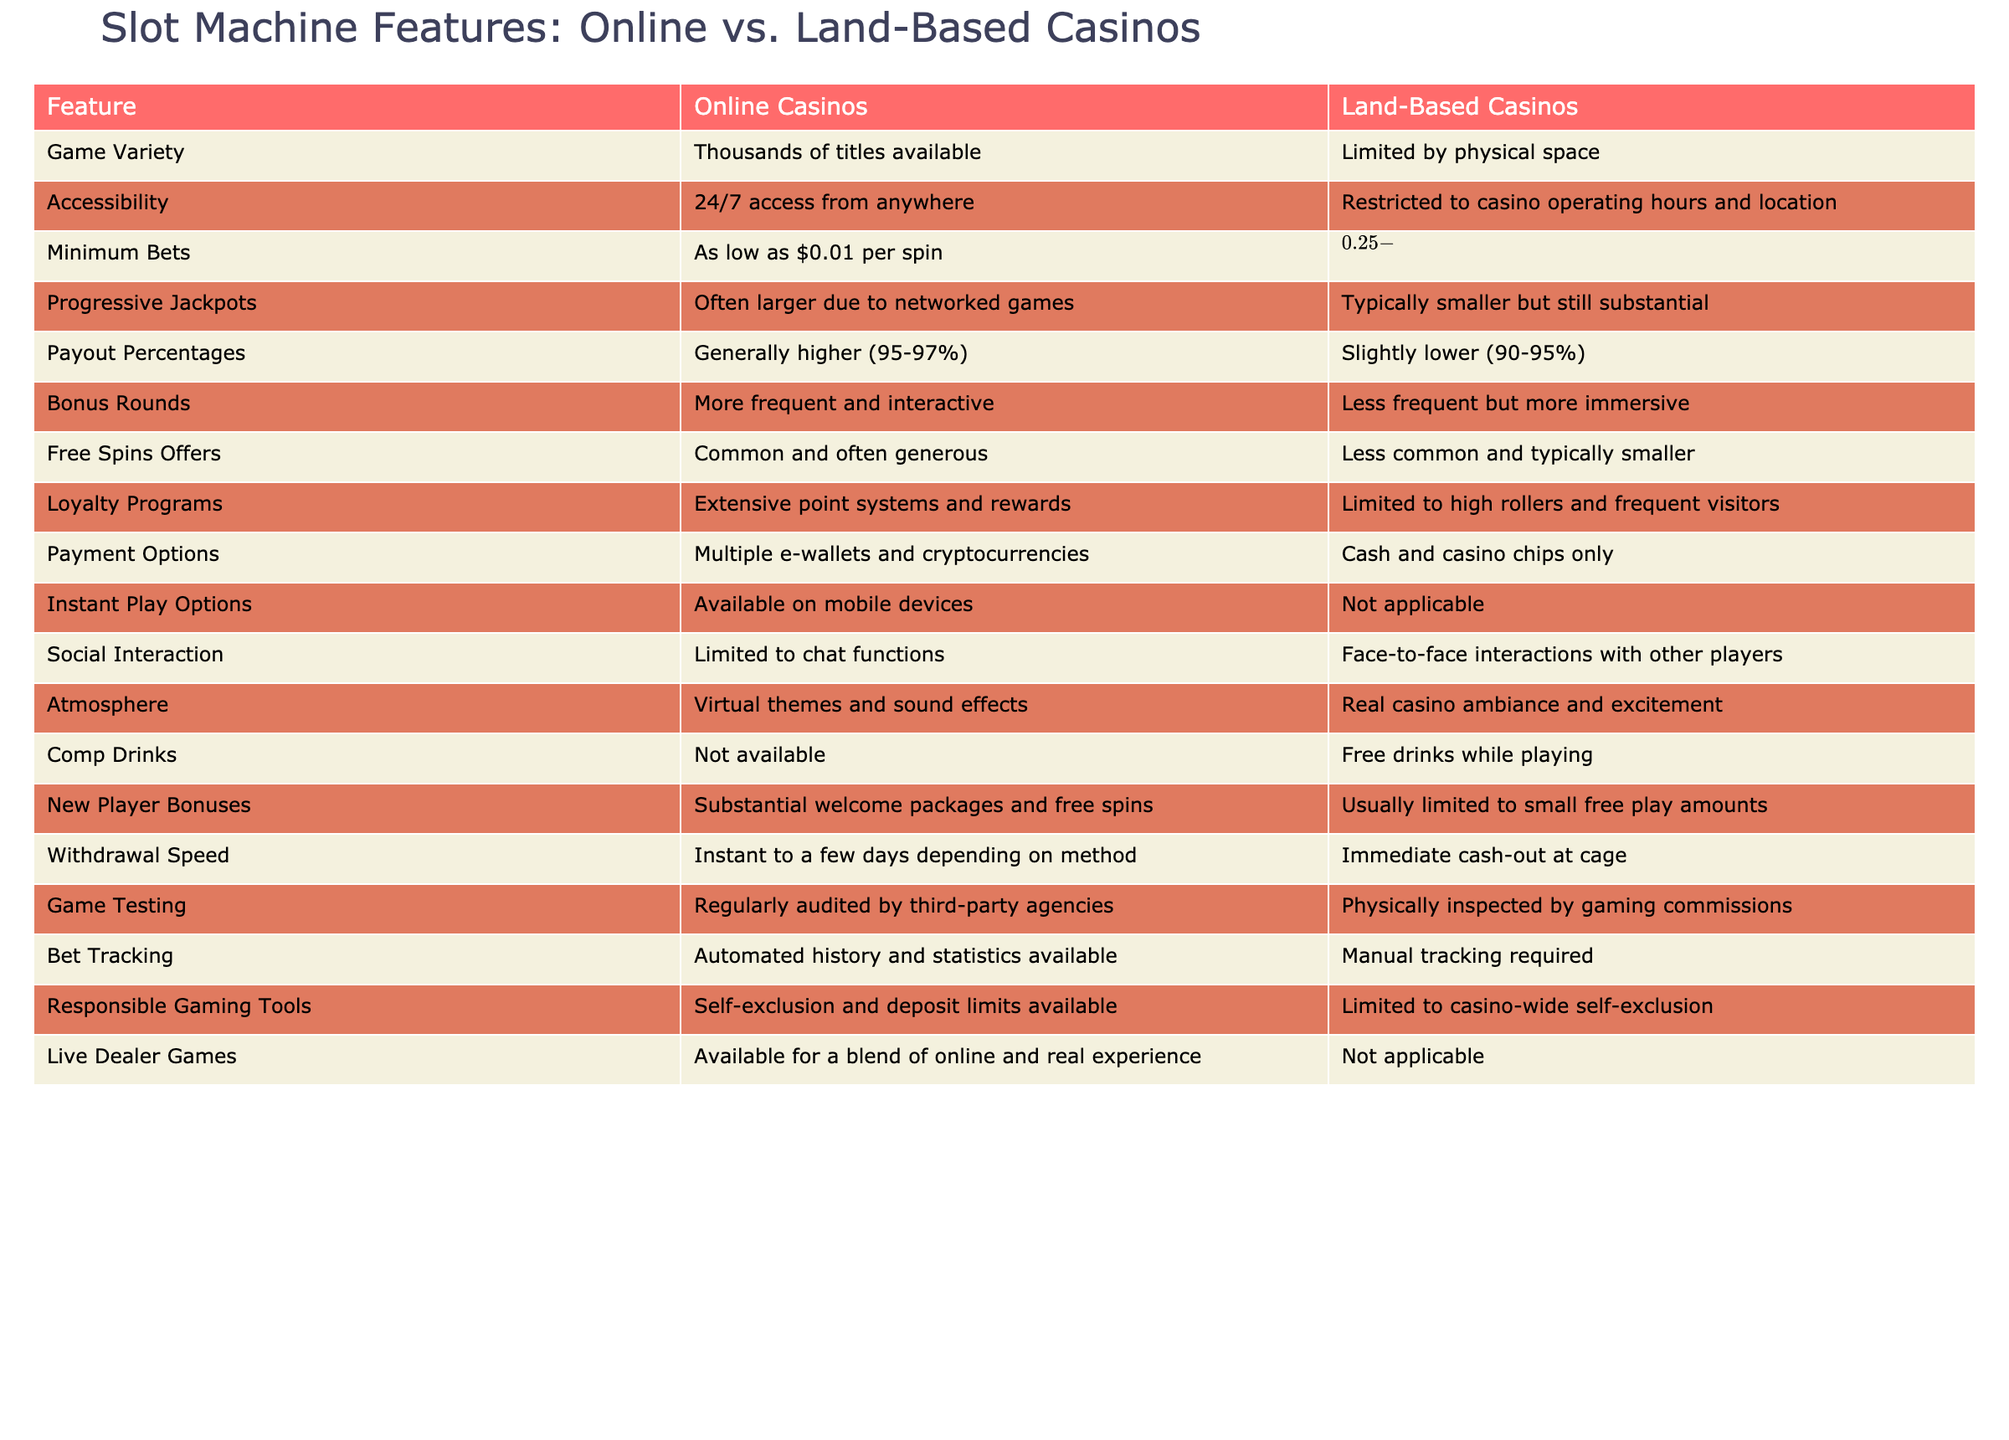What is the minimum bet in online casinos? The table indicates that minimum bets in online casinos can be as low as $0.01 per spin. This is a specific value found directly in the 'Minimum Bets' row for online casinos.
Answer: $0.01 Which has a larger variety of games available? Referring to the 'Game Variety' row, online casinos have thousands of titles available, while land-based casinos are limited by physical space. Hence, online casinos offer a larger variety.
Answer: Online casinos Are loyalty programs more extensive in online casinos? The table shows that online casinos have extensive point systems and rewards for their loyalty programs compared to land-based casinos, which are limited to high rollers and frequent visitors. Therefore, the statement is true.
Answer: Yes What is the difference in payout percentages between online and land-based casinos? According to the 'Payout Percentages' row, online casinos generally have payout percentages of 95-97%, while land-based casinos have slightly lower percentages of 90-95%. The difference indicates that online casinos have better payout percentages.
Answer: 5-7% Which provides faster withdrawal speeds? The 'Withdrawal Speed' row notes that online casinos can offer instant withdrawals to a few days depending on the method, while land-based casinos provide immediate cash-out at the cage. Since both have different aspects of speed, comparing them directly suggests that land-based casinos allow for at least an immediate payout.
Answer: Land-based casinos How often are free spins offers available in online casinos compared to land-based ones? In examining the 'Free Spins Offers' row, it's clear that free spins offers are common and often generous in online casinos, while they are less common and typically smaller in land-based casinos. This indicates that online casinos provide better opportunities for free spins.
Answer: More common in online casinos Is it true that you can play live dealer games in land-based casinos? The table mentions that live dealer games are available in online casinos, but explicitly states that this option is not applicable to land-based casinos. therefore, the statement is false.
Answer: No What is the main advantage of social interaction in land-based casinos? From the 'Social Interaction' row, it is stated that land-based casinos offer face-to-face interactions with other players, which is a significant advantage compared to the limited chat functions in online casinos. Consequently, the main advantage of social interaction in land-based casinos is the personal connection.
Answer: Face-to-face interactions How do the bonus rounds in online casinos compare to those in land-based casinos? Referring to the 'Bonus Rounds' row, online casinos have more frequent and interactive bonus rounds, while land-based casinos offer less frequent but more immersive experiences. This highlights that bonus rounds are generally more abundant and engaging in online casinos.
Answer: More frequent in online casinos 